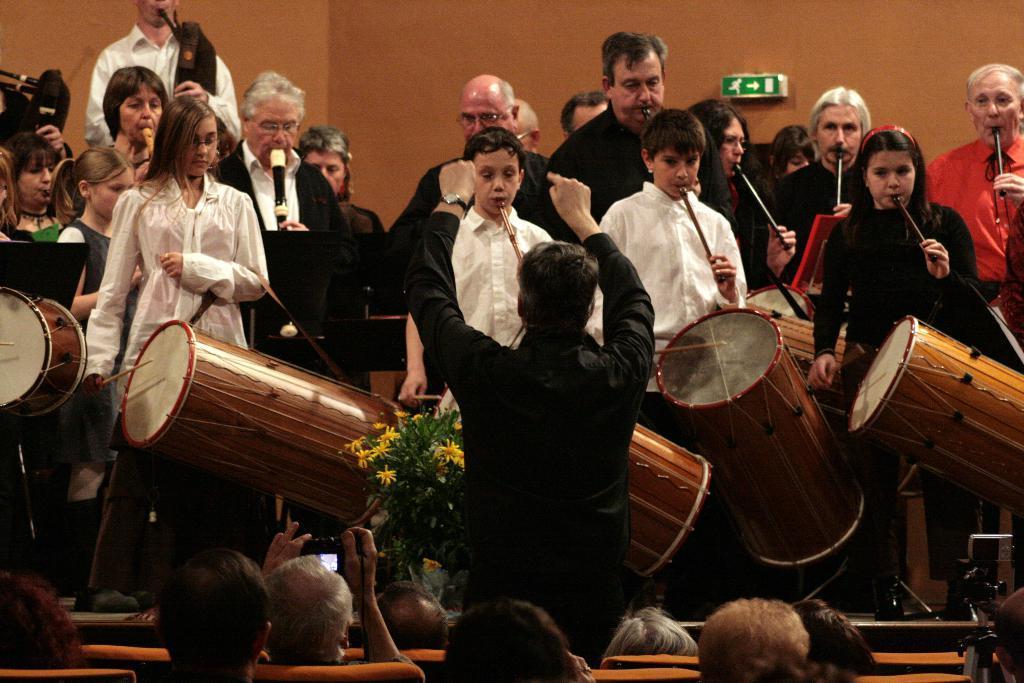In one or two sentences, can you explain what this image depicts? This image is clicked in a musical concert. There are so many people in this image. some of them are using flute and some of them are playing drums. There are people sitting in the bottom of chairs. 